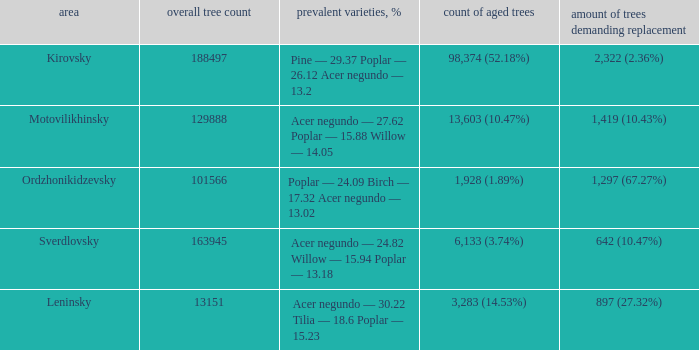What is the amount of trees, that require replacement when district is leninsky? 897 (27.32%). 